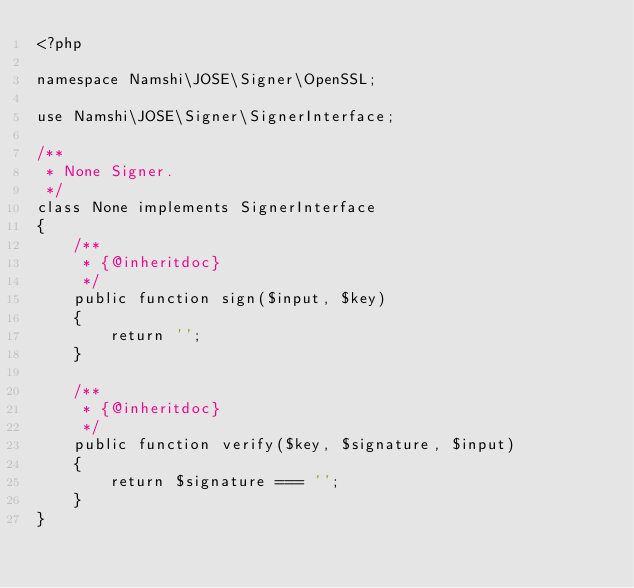<code> <loc_0><loc_0><loc_500><loc_500><_PHP_><?php

namespace Namshi\JOSE\Signer\OpenSSL;

use Namshi\JOSE\Signer\SignerInterface;

/**
 * None Signer.
 */
class None implements SignerInterface
{
    /**
     * {@inheritdoc}
     */
    public function sign($input, $key)
    {
        return '';
    }

    /**
     * {@inheritdoc}
     */
    public function verify($key, $signature, $input)
    {
        return $signature === '';
    }
}
</code> 